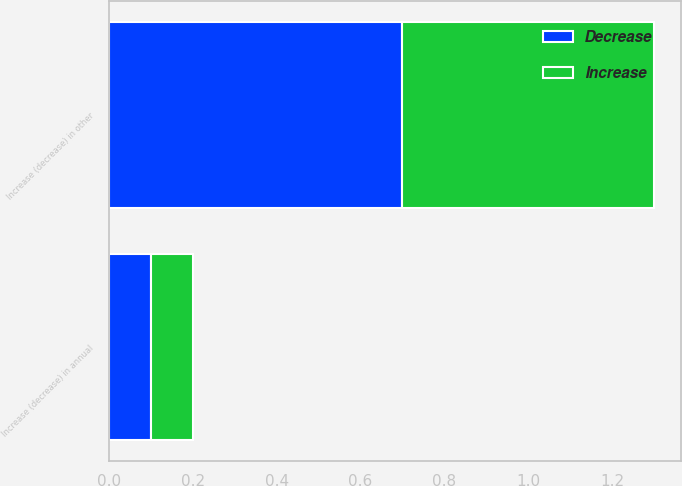Convert chart. <chart><loc_0><loc_0><loc_500><loc_500><stacked_bar_chart><ecel><fcel>Increase (decrease) in annual<fcel>Increase (decrease) in other<nl><fcel>Decrease<fcel>0.1<fcel>0.7<nl><fcel>Increase<fcel>0.1<fcel>0.6<nl></chart> 